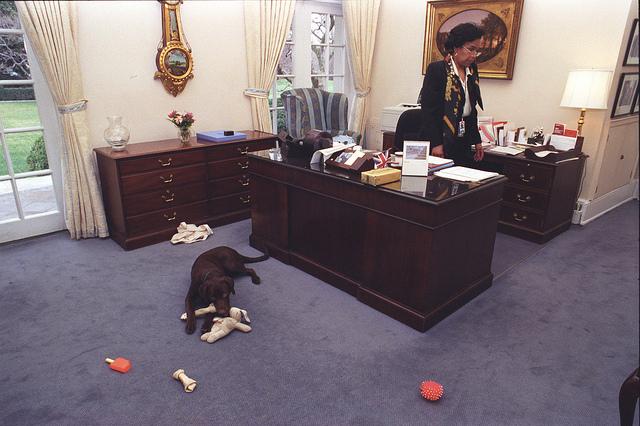Is that a bad dog?
Give a very brief answer. No. What kind of animal is on the carpet?
Keep it brief. Dog. Is this an office?
Be succinct. Yes. 